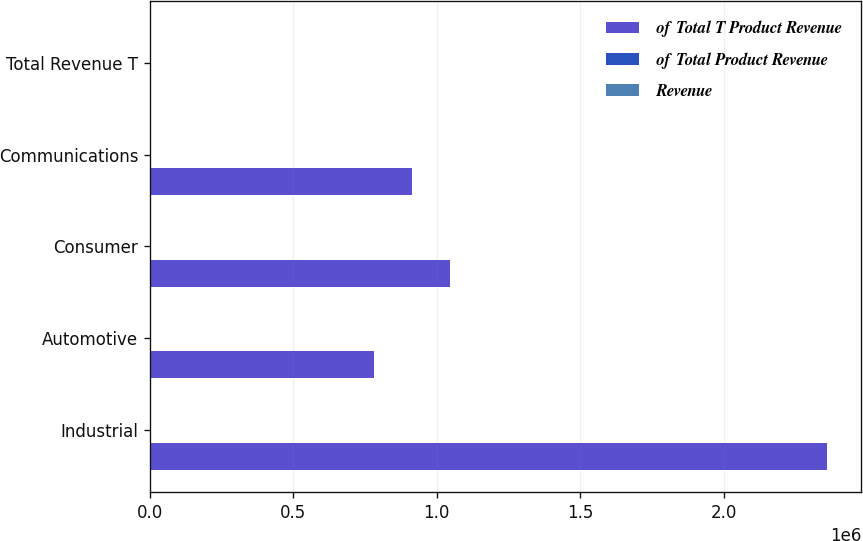Convert chart to OTSL. <chart><loc_0><loc_0><loc_500><loc_500><stacked_bar_chart><ecel><fcel>Industrial<fcel>Automotive<fcel>Consumer<fcel>Communications<fcel>Total Revenue T<nl><fcel>of Total T Product Revenue<fcel>2.36155e+06<fcel>782961<fcel>1.04761e+06<fcel>915387<fcel>45<nl><fcel>of Total Product Revenue<fcel>46<fcel>15<fcel>21<fcel>18<fcel>100<nl><fcel>Revenue<fcel>44<fcel>15<fcel>21<fcel>20<fcel>100<nl></chart> 